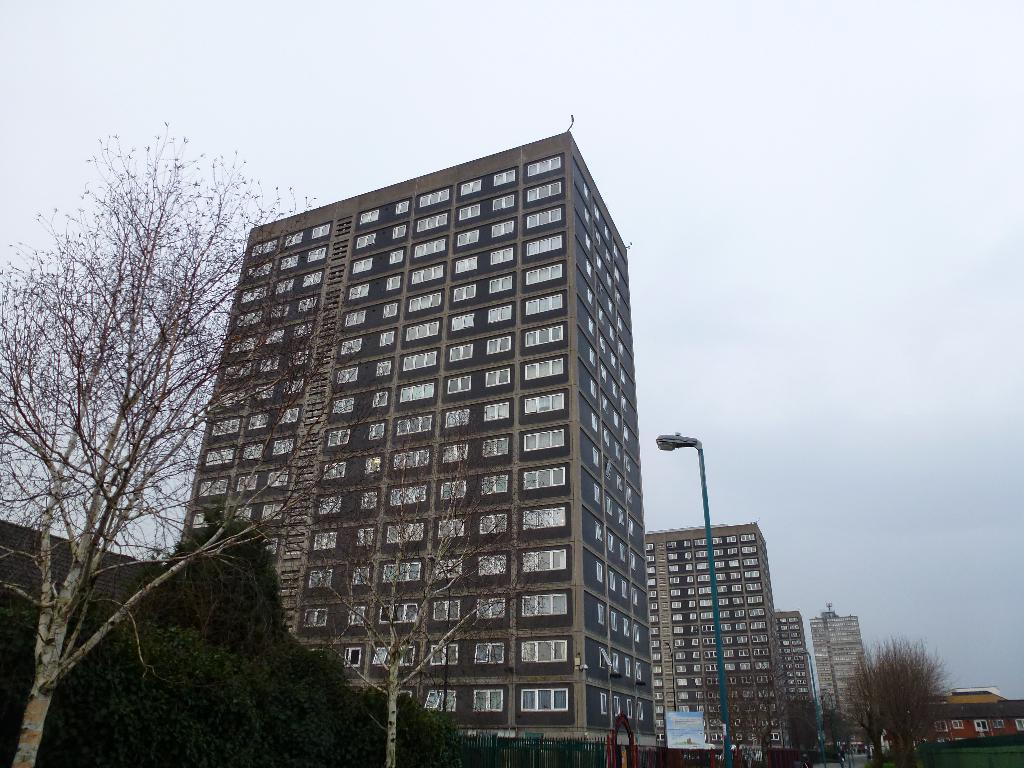What type of structures are visible in the image? There are buildings with windows in the image. What other natural elements can be seen in the image? There are trees in the image. What is the purpose of the tall, vertical object in the image? There is a light pole in the image, which is likely used for illuminating the area. What is visible in the background of the image? The sky is visible in the image. What type of jam is being served at the church in the image? There is no church or jam present in the image. Is there a volleyball game happening in the image? There is no volleyball game or any indication of sports activities in the image. 